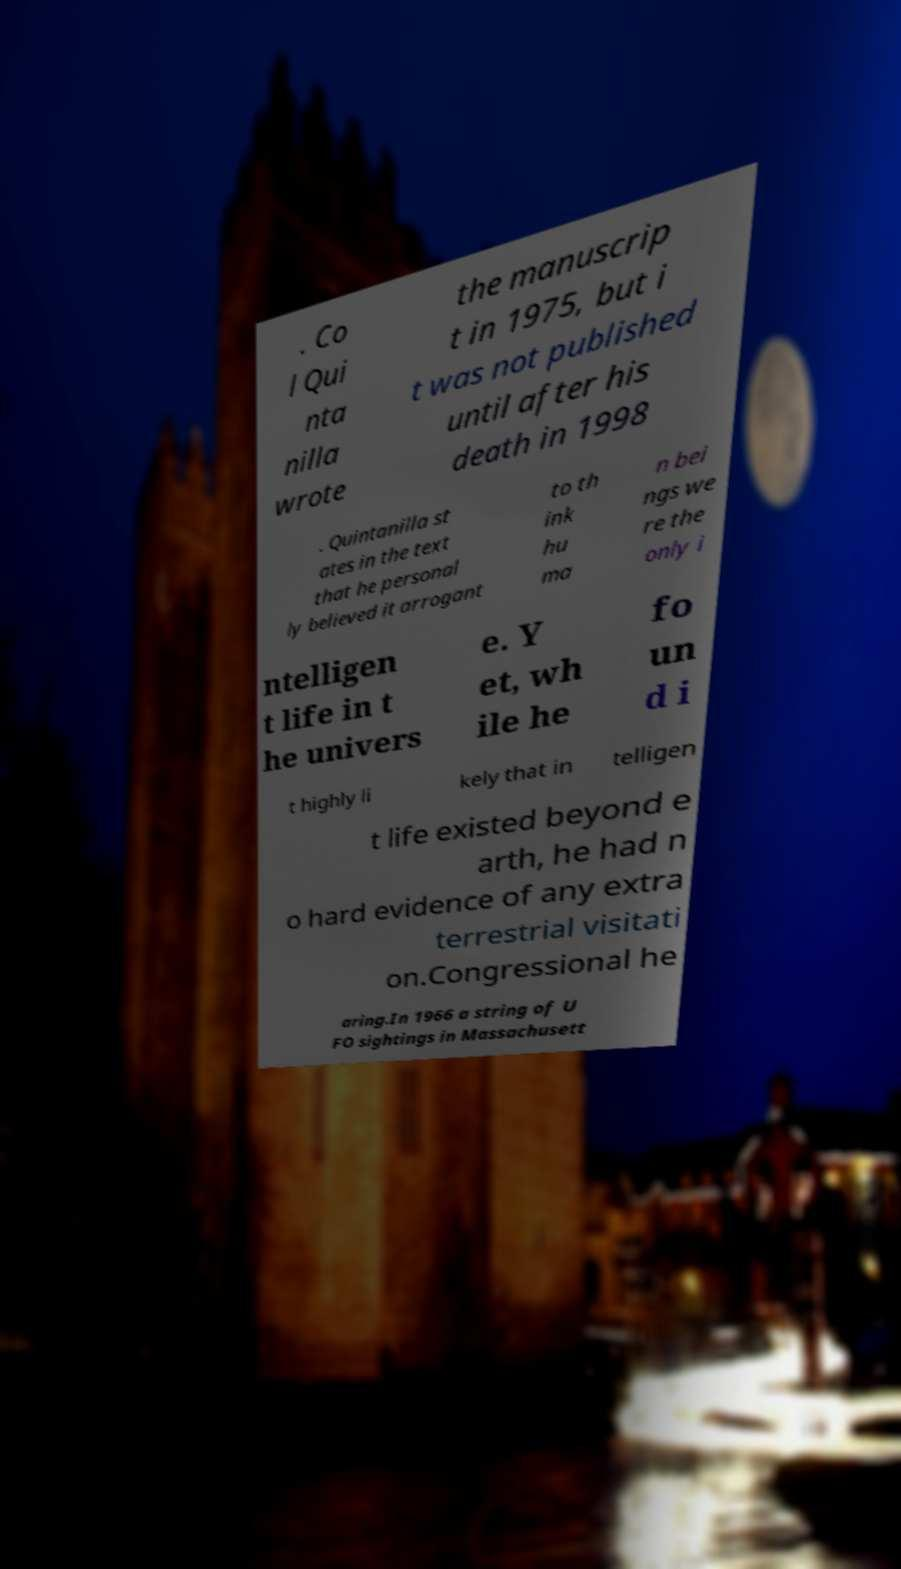For documentation purposes, I need the text within this image transcribed. Could you provide that? . Co l Qui nta nilla wrote the manuscrip t in 1975, but i t was not published until after his death in 1998 . Quintanilla st ates in the text that he personal ly believed it arrogant to th ink hu ma n bei ngs we re the only i ntelligen t life in t he univers e. Y et, wh ile he fo un d i t highly li kely that in telligen t life existed beyond e arth, he had n o hard evidence of any extra terrestrial visitati on.Congressional he aring.In 1966 a string of U FO sightings in Massachusett 